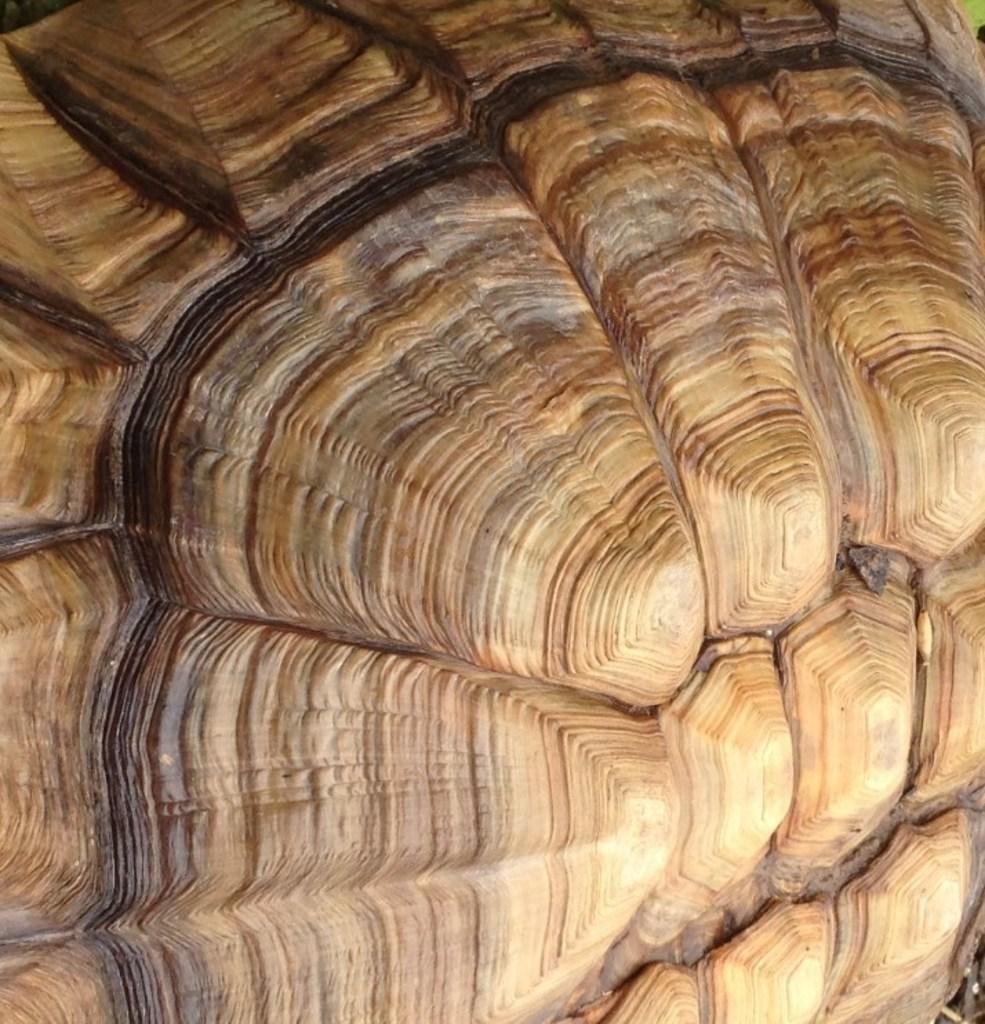In one or two sentences, can you explain what this image depicts? In this image we can see one object looks like rock, two objects on the ground looks like rock, some object on the top and bottom right side corner of the image. 